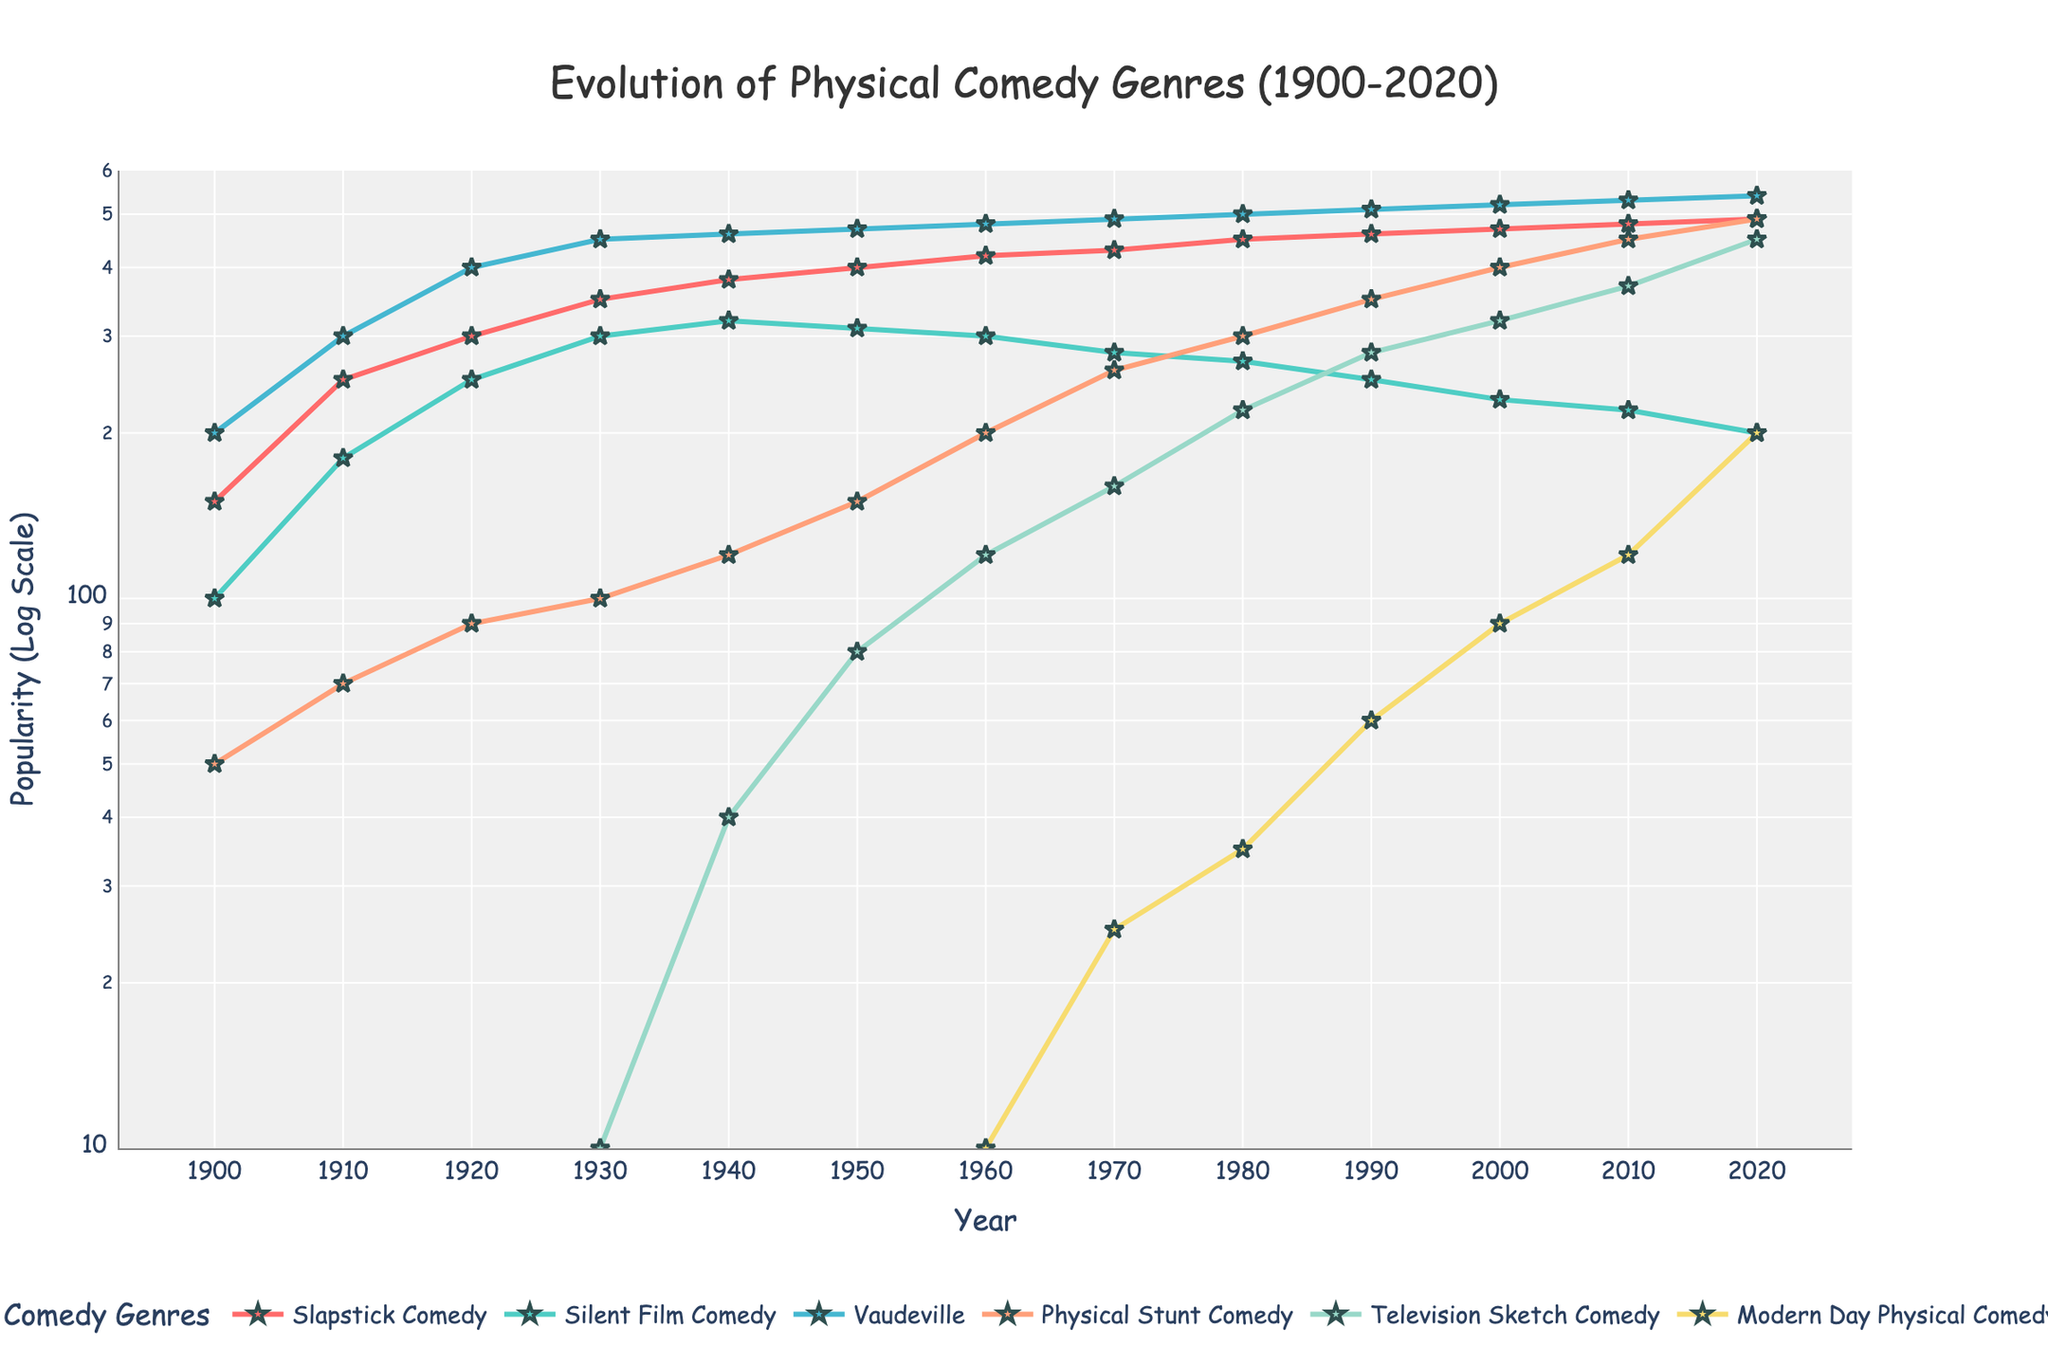What's the title of the figure? The title is located at the top center of the figure. It provides a summary of what the figure represents. By looking at the title, we can understand the main topic of the plot.
Answer: Evolution of Physical Comedy Genres (1900-2020) What is the y-axis labeled as? The y-axis label is positioned along the vertical axis on the left side of the figure. It tells us what the values along the y-axis represent.
Answer: Popularity (Log Scale) How many different comedy genres are illustrated in the plot? Each genre is represented by different colored lines and is named in the legend located below the plot. By counting the number of items in the legend, we can determine the number of genres.
Answer: 6 Which genre experienced the highest popularity in 1920? To identify this, locate the year 1920 on the x-axis and trace vertically upwards through all genre lines. The line that reaches the highest y-value in that year represents the most popular genre.
Answer: Vaudeville Between which years did Slapstick Comedy experience the greatest increase in popularity? To find this, observe the trend of Slapstick Comedy line across different time periods and look for the segment where the line has the steepest slope upwards, indicating the greatest increase.
Answer: 1900-1910 Which genre crossed a popularity of 500 first, and in which year? To determine this, observe the y-values on the log scale and find the genre line that first intersects the 500 mark. Then, locate the corresponding year on the x-axis.
Answer: Vaudeville in 1920 By how much did the popularity of Silent Film Comedy decrease from 1930 to 2020? Find the values of Silent Film Comedy at the years 1930 and 2020, and calculate the difference by subtracting the latter value from the former value.
Answer: 300 - 200 = 100 In which year did Modern Day Physical Comedy surpass the 100 popularity mark? Locate the point on the timeline where the line representing Modern Day Physical Comedy crosses the 100 mark on the log-scaled y-axis.
Answer: 2010 Compare the popularity of Television Sketch Comedy and Physical Stunt Comedy in 1980. Which one was more popular and by how much? Find the points on the plot for both genres in 1980 and note their y-values. Subtract the y-value of Television Sketch Comedy from that of Physical Stunt Comedy to determine the difference.
Answer: Physical Stunt Comedy by 300 - 220 = 80 What can be said about the overall trend of Vaudeville from 1900 to 2020? Examine the line representing Vaudeville from start to end across the years. Observe whether it shows an increasing, decreasing, or mixed trend to conclude its overall pattern.
Answer: Steadily increasing 